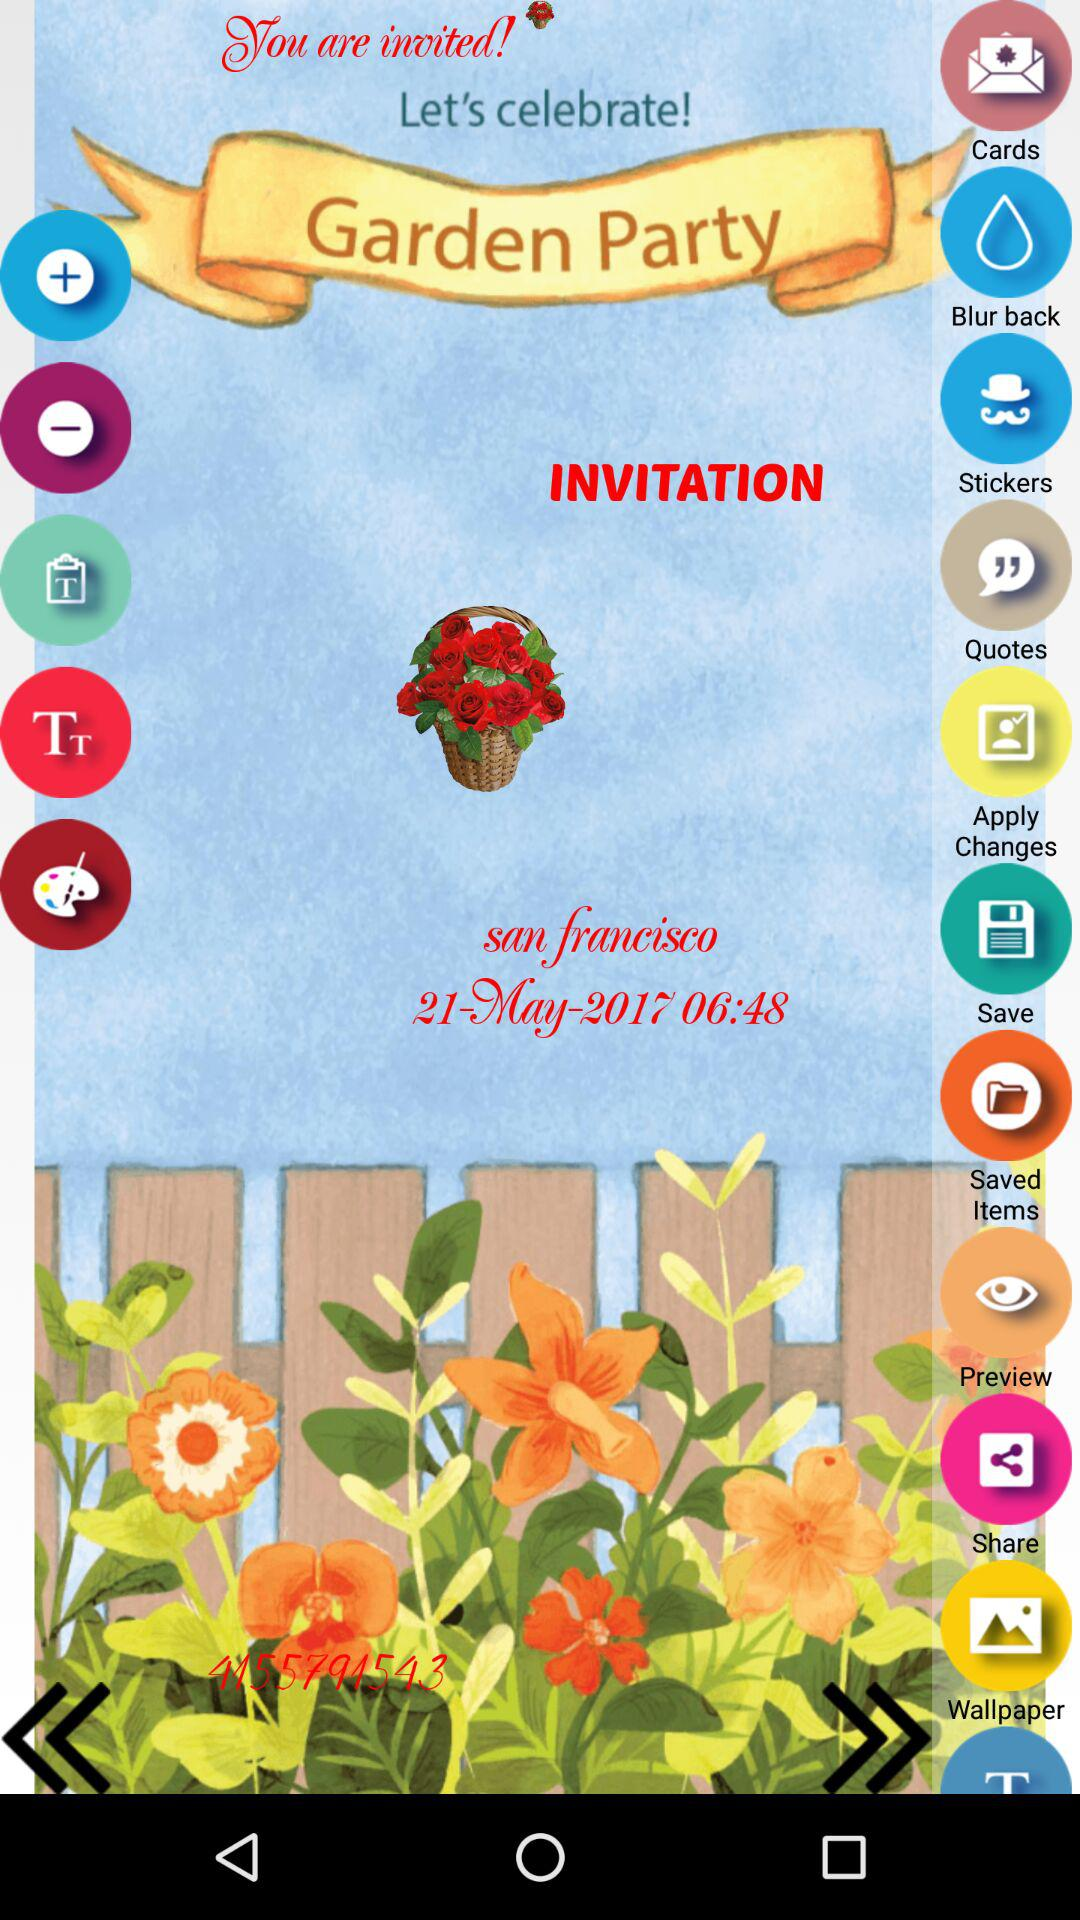What is the date and time of the party? The date and time of the party are May 21, 2017 at 06:48. 